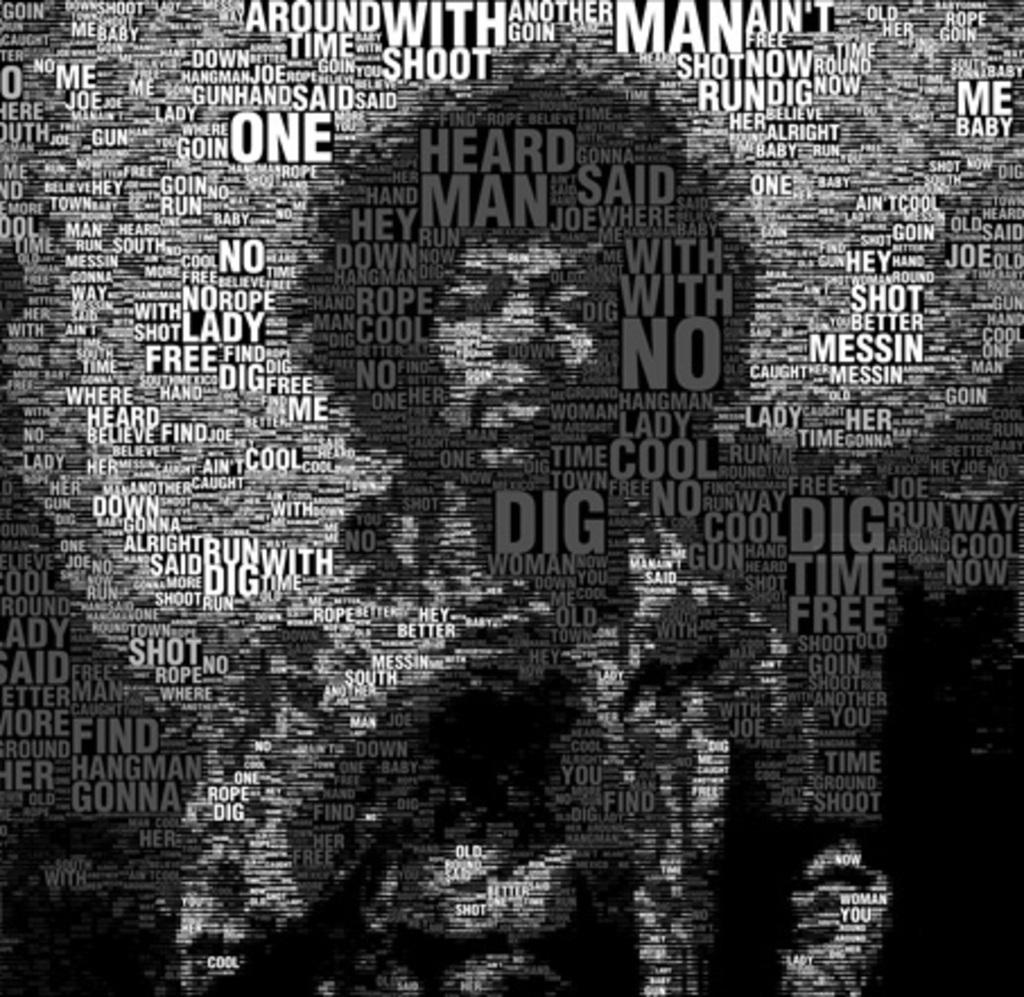<image>
Offer a succinct explanation of the picture presented. A Jimmy Hendrix poster made up of words like One, Heard, and Man. 